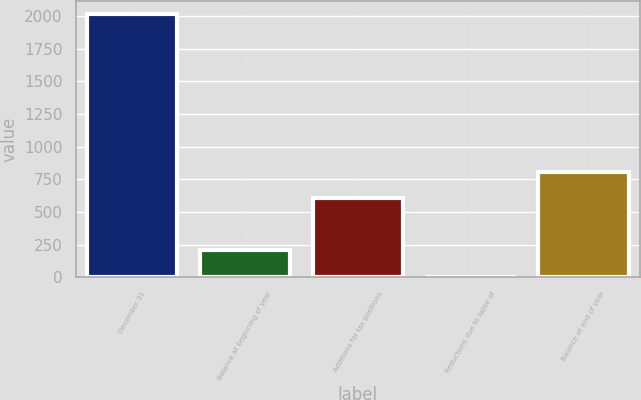Convert chart to OTSL. <chart><loc_0><loc_0><loc_500><loc_500><bar_chart><fcel>December 31<fcel>Balance at beginning of year<fcel>Additions for tax positions<fcel>Reductions due to lapse of<fcel>Balance at end of year<nl><fcel>2015<fcel>205.1<fcel>607.3<fcel>4<fcel>808.4<nl></chart> 